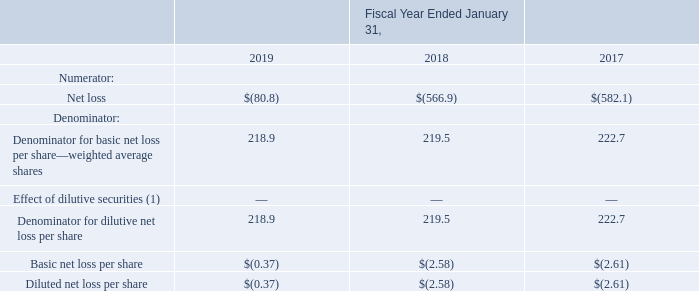13. Net Loss Per Share
Basic net loss per share is computed using the weighted average number of shares of common stock outstanding for the period, excluding stock options and restricted stock units. Diluted net loss per share is based upon the weighted average number of shares of common stock outstanding for the period and potentially dilutive common shares, including the effect of stock options and restricted stock units under the treasury stock method. The following table sets forth the computation of the numerators and denominators used in the basic and diluted net loss per share amounts:
(1) The effect of dilutive securities of 3.1 million, 4.5 million, and 4.6 million shares for the fiscal years ended January 31, 2019, 2018, and 2017, respectively, have been excluded from the calculation of diluted net loss per share as those shares would have been anti-dilutive due to the net loss incurred during those fiscal years.
The computation of diluted net loss per share does not include shares that are anti-dilutive under the treasury stock method because their exercise prices are higher than the average market value of Autodesk’s stock during the fiscal year. The effect of 0.5 million, 0.5 million, and 0.1 million potentially anti-dilutive shares were excluded from the computation of net loss per share for the fiscal years ended January 31, 2019, 2018, and 2017, respectively.
How is basic net loss per share calculated? Basic net loss per share is computed using the weighted average number of shares of common stock outstanding for the period, excluding stock options and restricted stock units. Why does the computation of diluted net loss per share does not include shares that are anti-dilutive under the treasury stock method? The computation of diluted net loss per share does not include shares that are anti-dilutive under the treasury stock method. What is the basic net loss per share in 2017? $(2.61). What is the change in the basic net loss per share from 2018 to 2019? 2.58-0.37
Answer: 2.21. What is the change in the numerator net loss from 2018 to 2019?
Answer scale should be: million. 566.9-80.8
Answer: 486.1. How much was the average basic net loss per share from 2017 to 2019? (0.37+2.58+2.61)/3 
Answer: 1.85. 